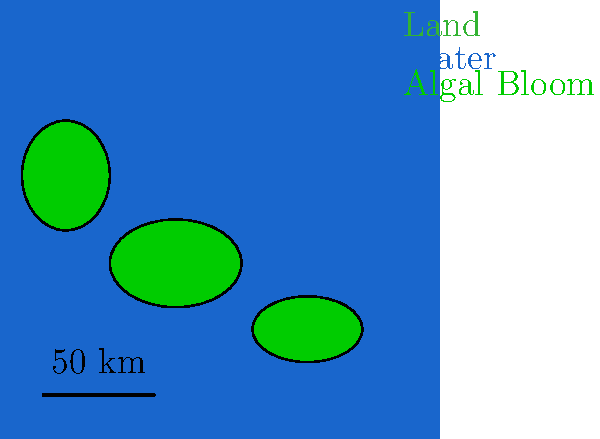Analyze the satellite imagery of a coastal area shown above. Which of the following statements best describes the distribution of algal blooms in relation to the coastline?

A) Algal blooms are concentrated primarily near river mouths
B) Algal blooms are evenly distributed along the entire coastline
C) Algal blooms are clustered in several distinct patches offshore
D) Algal blooms form a continuous band parallel to the shoreline To interpret this satellite imagery and determine the distribution of algal blooms, we need to follow these steps:

1. Identify the coastline: The brown area represents land, while the blue area represents water.

2. Locate the algal blooms: The bright green patches in the water area indicate algal blooms.

3. Analyze the distribution pattern:
   a) The algal blooms are not concentrated near any specific points along the coast that might represent river mouths.
   b) The blooms are not evenly spread along the entire coastline.
   c) We can see three distinct green patches in the offshore areas, forming clusters.
   d) The blooms do not form a continuous band parallel to the shore.

4. Compare the observed pattern with the given options:
   Option C best describes the situation we see in the image, where algal blooms are clustered in several distinct patches offshore.

This distribution pattern is common in coastal areas and can be influenced by factors such as nutrient availability, water temperature, and ocean currents. As a geographer studying human impacts on water bodies, understanding these patterns can help in identifying potential sources of nutrients (e.g., agricultural runoff or urban wastewater) that may be contributing to the algal bloom formation.
Answer: C) Algal blooms are clustered in several distinct patches offshore 